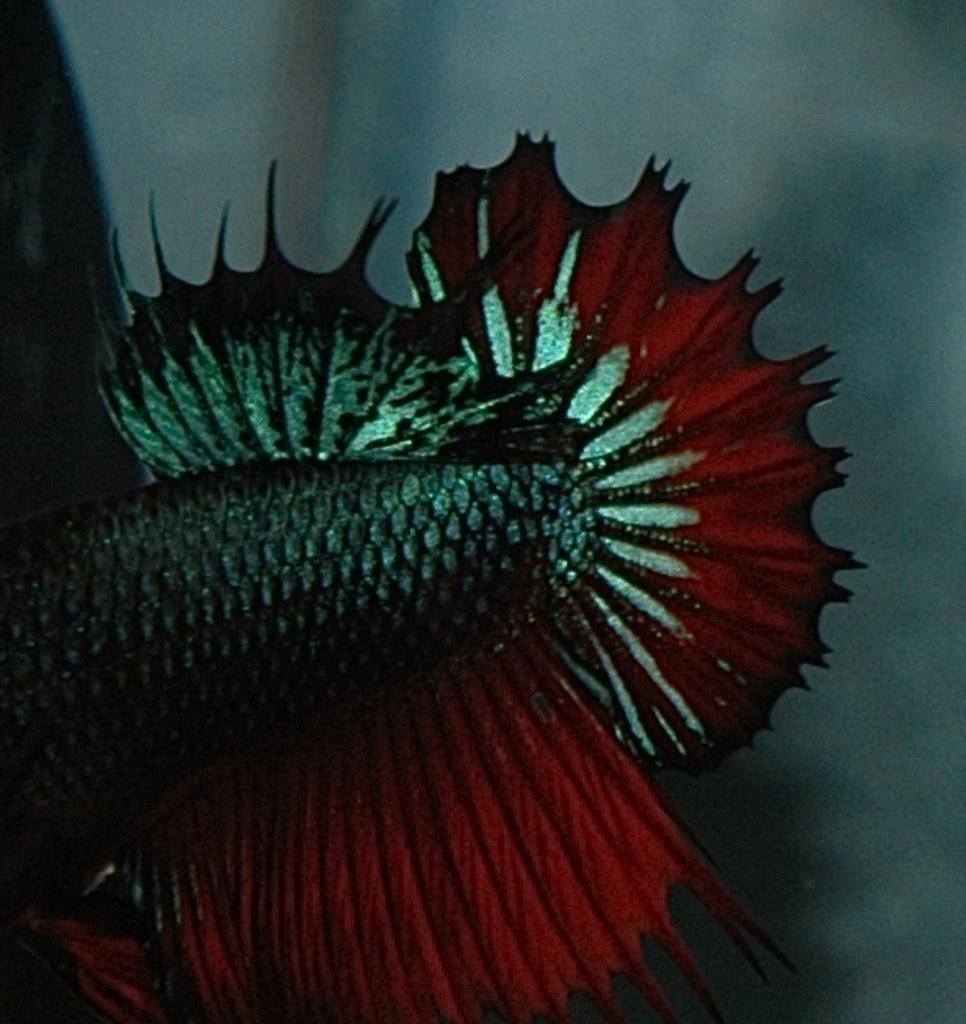What type of creature is depicted in the image? The image features the red fins of a fish. Can you describe any specific features of the fish? The only visible feature is the red fins. What type of flower is growing near the fish in the image? There is no flower present in the image; it only features the red fins of a fish. 